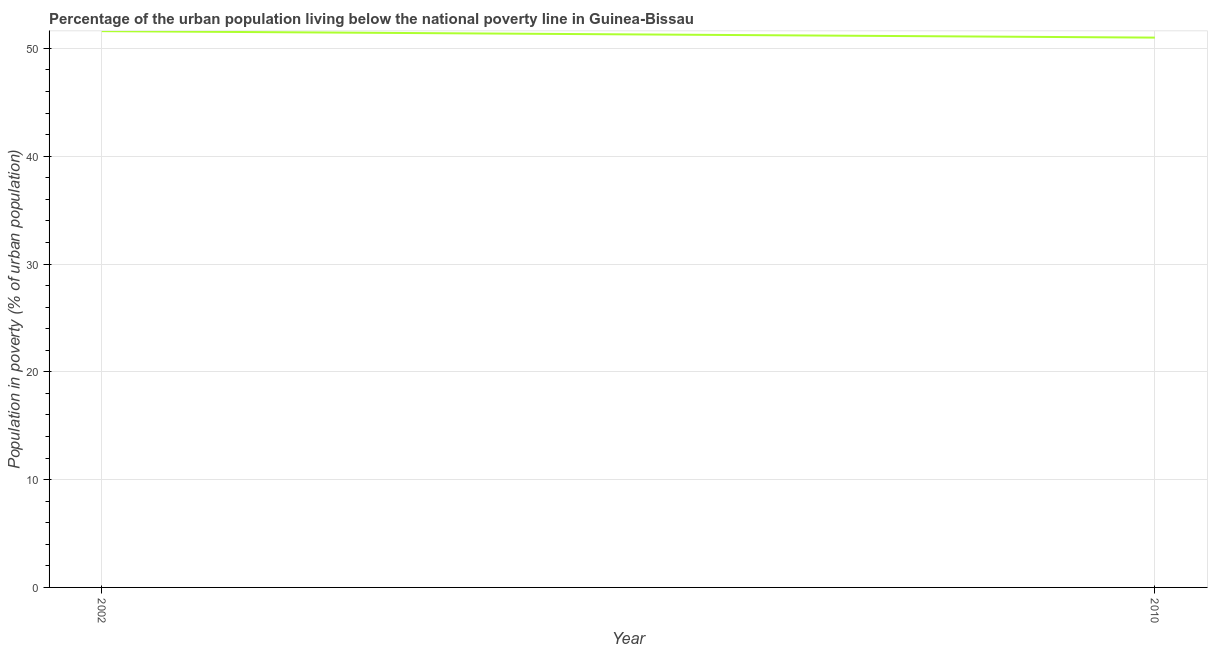What is the percentage of urban population living below poverty line in 2002?
Keep it short and to the point. 51.6. Across all years, what is the maximum percentage of urban population living below poverty line?
Give a very brief answer. 51.6. In which year was the percentage of urban population living below poverty line maximum?
Your answer should be compact. 2002. In which year was the percentage of urban population living below poverty line minimum?
Your answer should be compact. 2010. What is the sum of the percentage of urban population living below poverty line?
Your answer should be compact. 102.6. What is the difference between the percentage of urban population living below poverty line in 2002 and 2010?
Keep it short and to the point. 0.6. What is the average percentage of urban population living below poverty line per year?
Your answer should be compact. 51.3. What is the median percentage of urban population living below poverty line?
Keep it short and to the point. 51.3. In how many years, is the percentage of urban population living below poverty line greater than 2 %?
Ensure brevity in your answer.  2. What is the ratio of the percentage of urban population living below poverty line in 2002 to that in 2010?
Give a very brief answer. 1.01. How many lines are there?
Give a very brief answer. 1. How many years are there in the graph?
Keep it short and to the point. 2. Are the values on the major ticks of Y-axis written in scientific E-notation?
Your response must be concise. No. Does the graph contain any zero values?
Your answer should be compact. No. Does the graph contain grids?
Give a very brief answer. Yes. What is the title of the graph?
Give a very brief answer. Percentage of the urban population living below the national poverty line in Guinea-Bissau. What is the label or title of the Y-axis?
Give a very brief answer. Population in poverty (% of urban population). What is the Population in poverty (% of urban population) in 2002?
Provide a short and direct response. 51.6. What is the ratio of the Population in poverty (% of urban population) in 2002 to that in 2010?
Your answer should be very brief. 1.01. 